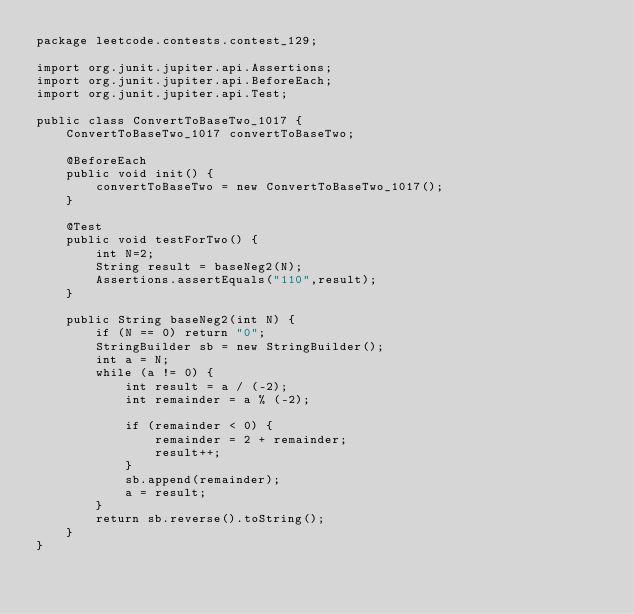<code> <loc_0><loc_0><loc_500><loc_500><_Java_>package leetcode.contests.contest_129;

import org.junit.jupiter.api.Assertions;
import org.junit.jupiter.api.BeforeEach;
import org.junit.jupiter.api.Test;

public class ConvertToBaseTwo_1017 {
    ConvertToBaseTwo_1017 convertToBaseTwo;

    @BeforeEach
    public void init() {
        convertToBaseTwo = new ConvertToBaseTwo_1017();
    }

    @Test
    public void testForTwo() {
        int N=2;
        String result = baseNeg2(N);
        Assertions.assertEquals("110",result);
    }

    public String baseNeg2(int N) {
        if (N == 0) return "0";
        StringBuilder sb = new StringBuilder();
        int a = N;
        while (a != 0) {
            int result = a / (-2);
            int remainder = a % (-2);

            if (remainder < 0) {
                remainder = 2 + remainder;
                result++;
            }
            sb.append(remainder);
            a = result;
        }
        return sb.reverse().toString();
    }
}
</code> 